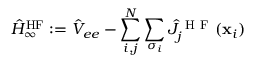<formula> <loc_0><loc_0><loc_500><loc_500>\hat { H } _ { \infty } ^ { H F } \colon = \hat { V } _ { e e } - \sum _ { i , j } ^ { N } \sum _ { \sigma _ { i } } \hat { J } _ { j } ^ { H F } ( x _ { i } )</formula> 